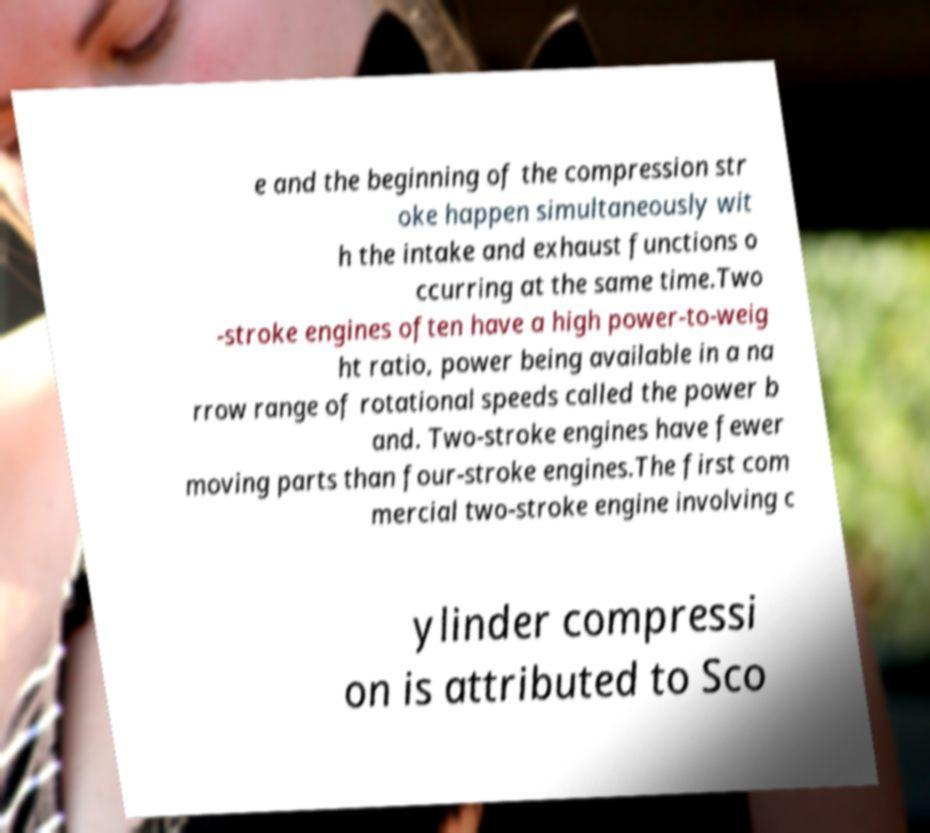Please identify and transcribe the text found in this image. e and the beginning of the compression str oke happen simultaneously wit h the intake and exhaust functions o ccurring at the same time.Two -stroke engines often have a high power-to-weig ht ratio, power being available in a na rrow range of rotational speeds called the power b and. Two-stroke engines have fewer moving parts than four-stroke engines.The first com mercial two-stroke engine involving c ylinder compressi on is attributed to Sco 